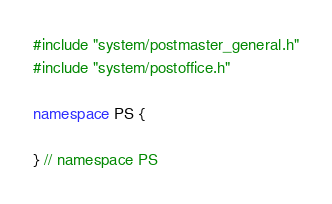Convert code to text. <code><loc_0><loc_0><loc_500><loc_500><_C++_>#include "system/postmaster_general.h"
#include "system/postoffice.h"

namespace PS {

} // namespace PS
</code> 